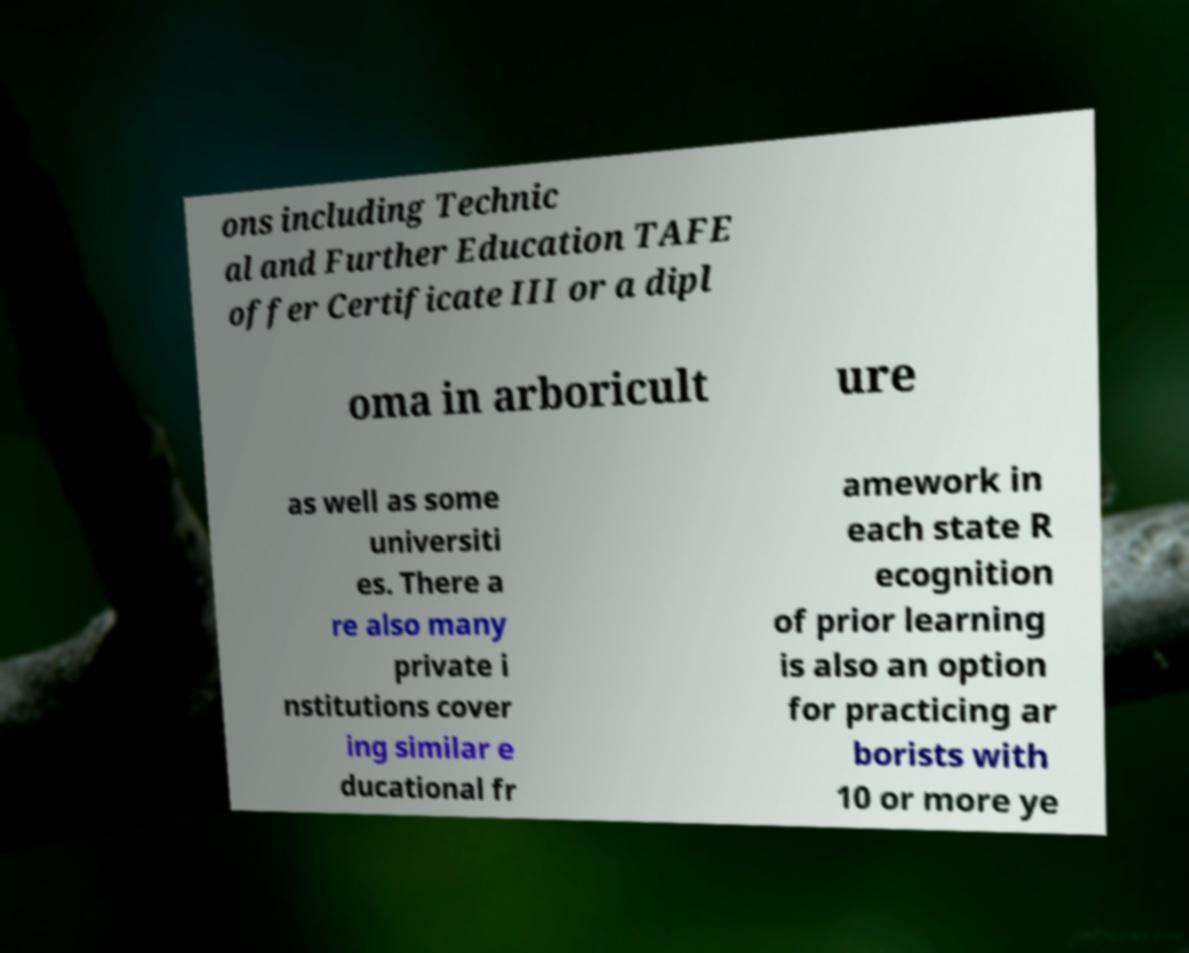Could you assist in decoding the text presented in this image and type it out clearly? ons including Technic al and Further Education TAFE offer Certificate III or a dipl oma in arboricult ure as well as some universiti es. There a re also many private i nstitutions cover ing similar e ducational fr amework in each state R ecognition of prior learning is also an option for practicing ar borists with 10 or more ye 